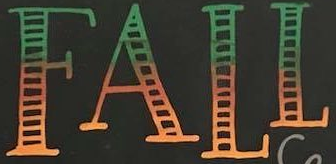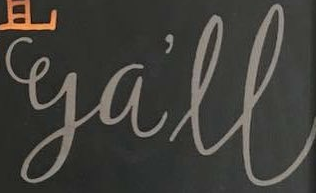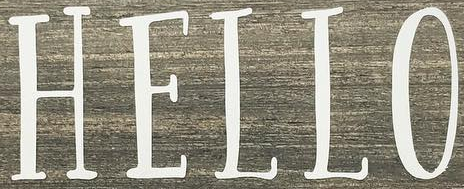Transcribe the words shown in these images in order, separated by a semicolon. FALL; ga'll; HELLO 